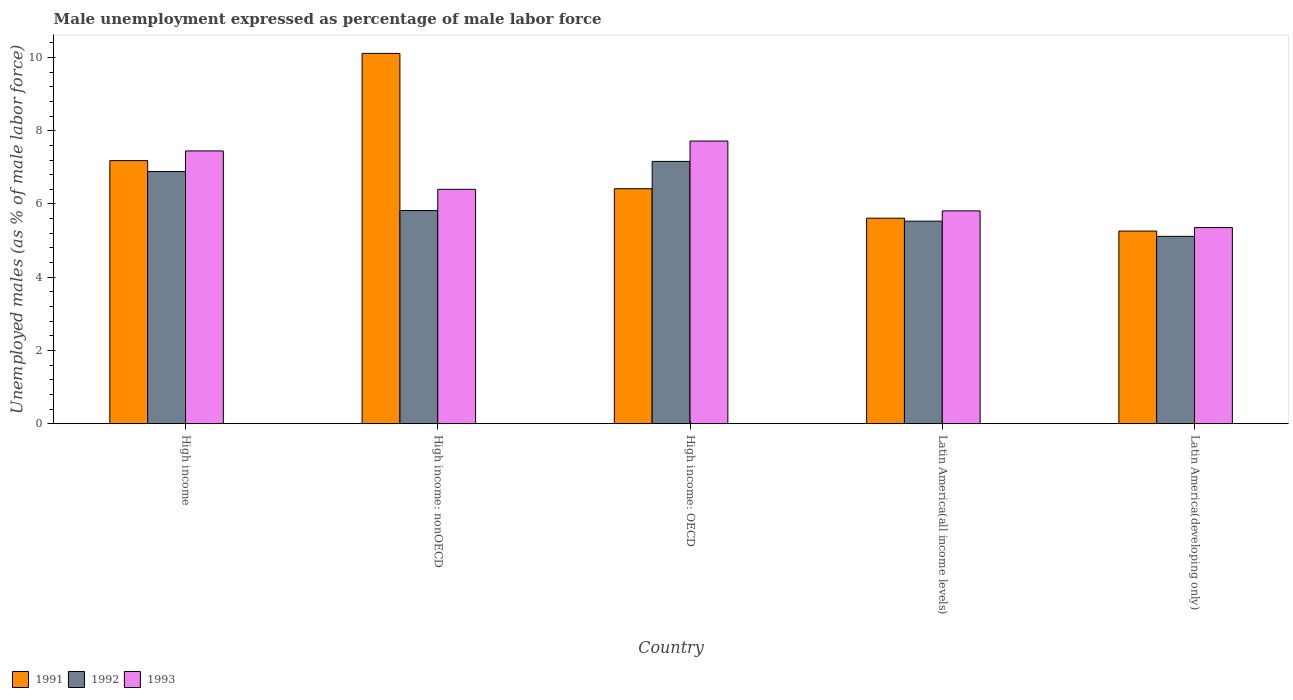How many groups of bars are there?
Make the answer very short. 5. Are the number of bars per tick equal to the number of legend labels?
Give a very brief answer. Yes. Are the number of bars on each tick of the X-axis equal?
Your answer should be compact. Yes. How many bars are there on the 3rd tick from the left?
Your answer should be compact. 3. What is the label of the 3rd group of bars from the left?
Ensure brevity in your answer.  High income: OECD. What is the unemployment in males in in 1992 in Latin America(developing only)?
Ensure brevity in your answer.  5.12. Across all countries, what is the maximum unemployment in males in in 1992?
Offer a terse response. 7.16. Across all countries, what is the minimum unemployment in males in in 1993?
Your response must be concise. 5.36. In which country was the unemployment in males in in 1993 maximum?
Offer a terse response. High income: OECD. In which country was the unemployment in males in in 1993 minimum?
Your response must be concise. Latin America(developing only). What is the total unemployment in males in in 1991 in the graph?
Offer a very short reply. 34.59. What is the difference between the unemployment in males in in 1993 in High income: nonOECD and that in Latin America(developing only)?
Your answer should be compact. 1.04. What is the difference between the unemployment in males in in 1993 in Latin America(all income levels) and the unemployment in males in in 1991 in High income: OECD?
Make the answer very short. -0.6. What is the average unemployment in males in in 1992 per country?
Offer a very short reply. 6.1. What is the difference between the unemployment in males in of/in 1991 and unemployment in males in of/in 1992 in High income: OECD?
Provide a short and direct response. -0.75. What is the ratio of the unemployment in males in in 1992 in High income: OECD to that in Latin America(developing only)?
Offer a terse response. 1.4. Is the unemployment in males in in 1993 in Latin America(all income levels) less than that in Latin America(developing only)?
Offer a very short reply. No. Is the difference between the unemployment in males in in 1991 in High income: OECD and High income: nonOECD greater than the difference between the unemployment in males in in 1992 in High income: OECD and High income: nonOECD?
Give a very brief answer. No. What is the difference between the highest and the second highest unemployment in males in in 1993?
Provide a succinct answer. 1.05. What is the difference between the highest and the lowest unemployment in males in in 1992?
Make the answer very short. 2.05. In how many countries, is the unemployment in males in in 1991 greater than the average unemployment in males in in 1991 taken over all countries?
Provide a succinct answer. 2. Is the sum of the unemployment in males in in 1992 in High income: OECD and High income: nonOECD greater than the maximum unemployment in males in in 1991 across all countries?
Your answer should be very brief. Yes. Are all the bars in the graph horizontal?
Ensure brevity in your answer.  No. What is the difference between two consecutive major ticks on the Y-axis?
Offer a terse response. 2. Does the graph contain any zero values?
Offer a very short reply. No. Where does the legend appear in the graph?
Provide a succinct answer. Bottom left. How are the legend labels stacked?
Offer a very short reply. Horizontal. What is the title of the graph?
Your response must be concise. Male unemployment expressed as percentage of male labor force. What is the label or title of the X-axis?
Give a very brief answer. Country. What is the label or title of the Y-axis?
Offer a very short reply. Unemployed males (as % of male labor force). What is the Unemployed males (as % of male labor force) of 1991 in High income?
Make the answer very short. 7.18. What is the Unemployed males (as % of male labor force) in 1992 in High income?
Provide a short and direct response. 6.89. What is the Unemployed males (as % of male labor force) of 1993 in High income?
Offer a very short reply. 7.45. What is the Unemployed males (as % of male labor force) of 1991 in High income: nonOECD?
Ensure brevity in your answer.  10.11. What is the Unemployed males (as % of male labor force) of 1992 in High income: nonOECD?
Your answer should be very brief. 5.82. What is the Unemployed males (as % of male labor force) in 1993 in High income: nonOECD?
Your response must be concise. 6.4. What is the Unemployed males (as % of male labor force) of 1991 in High income: OECD?
Offer a very short reply. 6.42. What is the Unemployed males (as % of male labor force) in 1992 in High income: OECD?
Your answer should be compact. 7.16. What is the Unemployed males (as % of male labor force) in 1993 in High income: OECD?
Offer a terse response. 7.72. What is the Unemployed males (as % of male labor force) in 1991 in Latin America(all income levels)?
Provide a short and direct response. 5.61. What is the Unemployed males (as % of male labor force) of 1992 in Latin America(all income levels)?
Make the answer very short. 5.53. What is the Unemployed males (as % of male labor force) of 1993 in Latin America(all income levels)?
Your answer should be very brief. 5.81. What is the Unemployed males (as % of male labor force) in 1991 in Latin America(developing only)?
Ensure brevity in your answer.  5.26. What is the Unemployed males (as % of male labor force) of 1992 in Latin America(developing only)?
Your answer should be very brief. 5.12. What is the Unemployed males (as % of male labor force) of 1993 in Latin America(developing only)?
Ensure brevity in your answer.  5.36. Across all countries, what is the maximum Unemployed males (as % of male labor force) in 1991?
Your response must be concise. 10.11. Across all countries, what is the maximum Unemployed males (as % of male labor force) in 1992?
Your answer should be compact. 7.16. Across all countries, what is the maximum Unemployed males (as % of male labor force) in 1993?
Your response must be concise. 7.72. Across all countries, what is the minimum Unemployed males (as % of male labor force) in 1991?
Provide a short and direct response. 5.26. Across all countries, what is the minimum Unemployed males (as % of male labor force) of 1992?
Provide a succinct answer. 5.12. Across all countries, what is the minimum Unemployed males (as % of male labor force) of 1993?
Make the answer very short. 5.36. What is the total Unemployed males (as % of male labor force) in 1991 in the graph?
Provide a short and direct response. 34.59. What is the total Unemployed males (as % of male labor force) in 1992 in the graph?
Your response must be concise. 30.52. What is the total Unemployed males (as % of male labor force) in 1993 in the graph?
Provide a succinct answer. 32.74. What is the difference between the Unemployed males (as % of male labor force) of 1991 in High income and that in High income: nonOECD?
Offer a terse response. -2.93. What is the difference between the Unemployed males (as % of male labor force) in 1992 in High income and that in High income: nonOECD?
Provide a succinct answer. 1.06. What is the difference between the Unemployed males (as % of male labor force) of 1993 in High income and that in High income: nonOECD?
Ensure brevity in your answer.  1.05. What is the difference between the Unemployed males (as % of male labor force) of 1991 in High income and that in High income: OECD?
Give a very brief answer. 0.77. What is the difference between the Unemployed males (as % of male labor force) of 1992 in High income and that in High income: OECD?
Provide a succinct answer. -0.28. What is the difference between the Unemployed males (as % of male labor force) of 1993 in High income and that in High income: OECD?
Ensure brevity in your answer.  -0.27. What is the difference between the Unemployed males (as % of male labor force) in 1991 in High income and that in Latin America(all income levels)?
Your answer should be very brief. 1.57. What is the difference between the Unemployed males (as % of male labor force) in 1992 in High income and that in Latin America(all income levels)?
Your answer should be compact. 1.36. What is the difference between the Unemployed males (as % of male labor force) of 1993 in High income and that in Latin America(all income levels)?
Make the answer very short. 1.64. What is the difference between the Unemployed males (as % of male labor force) in 1991 in High income and that in Latin America(developing only)?
Offer a very short reply. 1.92. What is the difference between the Unemployed males (as % of male labor force) in 1992 in High income and that in Latin America(developing only)?
Provide a succinct answer. 1.77. What is the difference between the Unemployed males (as % of male labor force) in 1993 in High income and that in Latin America(developing only)?
Give a very brief answer. 2.09. What is the difference between the Unemployed males (as % of male labor force) of 1991 in High income: nonOECD and that in High income: OECD?
Provide a succinct answer. 3.7. What is the difference between the Unemployed males (as % of male labor force) in 1992 in High income: nonOECD and that in High income: OECD?
Your response must be concise. -1.34. What is the difference between the Unemployed males (as % of male labor force) of 1993 in High income: nonOECD and that in High income: OECD?
Make the answer very short. -1.32. What is the difference between the Unemployed males (as % of male labor force) in 1991 in High income: nonOECD and that in Latin America(all income levels)?
Make the answer very short. 4.5. What is the difference between the Unemployed males (as % of male labor force) in 1992 in High income: nonOECD and that in Latin America(all income levels)?
Your response must be concise. 0.29. What is the difference between the Unemployed males (as % of male labor force) in 1993 in High income: nonOECD and that in Latin America(all income levels)?
Keep it short and to the point. 0.59. What is the difference between the Unemployed males (as % of male labor force) in 1991 in High income: nonOECD and that in Latin America(developing only)?
Offer a very short reply. 4.85. What is the difference between the Unemployed males (as % of male labor force) in 1992 in High income: nonOECD and that in Latin America(developing only)?
Provide a short and direct response. 0.7. What is the difference between the Unemployed males (as % of male labor force) of 1993 in High income: nonOECD and that in Latin America(developing only)?
Your answer should be very brief. 1.04. What is the difference between the Unemployed males (as % of male labor force) of 1991 in High income: OECD and that in Latin America(all income levels)?
Your answer should be very brief. 0.8. What is the difference between the Unemployed males (as % of male labor force) of 1992 in High income: OECD and that in Latin America(all income levels)?
Provide a short and direct response. 1.63. What is the difference between the Unemployed males (as % of male labor force) of 1993 in High income: OECD and that in Latin America(all income levels)?
Ensure brevity in your answer.  1.91. What is the difference between the Unemployed males (as % of male labor force) in 1991 in High income: OECD and that in Latin America(developing only)?
Provide a succinct answer. 1.16. What is the difference between the Unemployed males (as % of male labor force) of 1992 in High income: OECD and that in Latin America(developing only)?
Provide a short and direct response. 2.05. What is the difference between the Unemployed males (as % of male labor force) in 1993 in High income: OECD and that in Latin America(developing only)?
Provide a succinct answer. 2.36. What is the difference between the Unemployed males (as % of male labor force) of 1991 in Latin America(all income levels) and that in Latin America(developing only)?
Make the answer very short. 0.35. What is the difference between the Unemployed males (as % of male labor force) of 1992 in Latin America(all income levels) and that in Latin America(developing only)?
Offer a terse response. 0.41. What is the difference between the Unemployed males (as % of male labor force) of 1993 in Latin America(all income levels) and that in Latin America(developing only)?
Provide a short and direct response. 0.46. What is the difference between the Unemployed males (as % of male labor force) in 1991 in High income and the Unemployed males (as % of male labor force) in 1992 in High income: nonOECD?
Your answer should be very brief. 1.36. What is the difference between the Unemployed males (as % of male labor force) in 1991 in High income and the Unemployed males (as % of male labor force) in 1993 in High income: nonOECD?
Your response must be concise. 0.78. What is the difference between the Unemployed males (as % of male labor force) of 1992 in High income and the Unemployed males (as % of male labor force) of 1993 in High income: nonOECD?
Your answer should be compact. 0.49. What is the difference between the Unemployed males (as % of male labor force) in 1991 in High income and the Unemployed males (as % of male labor force) in 1992 in High income: OECD?
Provide a short and direct response. 0.02. What is the difference between the Unemployed males (as % of male labor force) of 1991 in High income and the Unemployed males (as % of male labor force) of 1993 in High income: OECD?
Give a very brief answer. -0.53. What is the difference between the Unemployed males (as % of male labor force) of 1992 in High income and the Unemployed males (as % of male labor force) of 1993 in High income: OECD?
Offer a terse response. -0.83. What is the difference between the Unemployed males (as % of male labor force) in 1991 in High income and the Unemployed males (as % of male labor force) in 1992 in Latin America(all income levels)?
Your answer should be compact. 1.65. What is the difference between the Unemployed males (as % of male labor force) of 1991 in High income and the Unemployed males (as % of male labor force) of 1993 in Latin America(all income levels)?
Your response must be concise. 1.37. What is the difference between the Unemployed males (as % of male labor force) of 1992 in High income and the Unemployed males (as % of male labor force) of 1993 in Latin America(all income levels)?
Your answer should be very brief. 1.07. What is the difference between the Unemployed males (as % of male labor force) of 1991 in High income and the Unemployed males (as % of male labor force) of 1992 in Latin America(developing only)?
Your response must be concise. 2.07. What is the difference between the Unemployed males (as % of male labor force) in 1991 in High income and the Unemployed males (as % of male labor force) in 1993 in Latin America(developing only)?
Your response must be concise. 1.83. What is the difference between the Unemployed males (as % of male labor force) of 1992 in High income and the Unemployed males (as % of male labor force) of 1993 in Latin America(developing only)?
Keep it short and to the point. 1.53. What is the difference between the Unemployed males (as % of male labor force) of 1991 in High income: nonOECD and the Unemployed males (as % of male labor force) of 1992 in High income: OECD?
Make the answer very short. 2.95. What is the difference between the Unemployed males (as % of male labor force) in 1991 in High income: nonOECD and the Unemployed males (as % of male labor force) in 1993 in High income: OECD?
Keep it short and to the point. 2.39. What is the difference between the Unemployed males (as % of male labor force) of 1992 in High income: nonOECD and the Unemployed males (as % of male labor force) of 1993 in High income: OECD?
Make the answer very short. -1.9. What is the difference between the Unemployed males (as % of male labor force) in 1991 in High income: nonOECD and the Unemployed males (as % of male labor force) in 1992 in Latin America(all income levels)?
Make the answer very short. 4.58. What is the difference between the Unemployed males (as % of male labor force) of 1991 in High income: nonOECD and the Unemployed males (as % of male labor force) of 1993 in Latin America(all income levels)?
Give a very brief answer. 4.3. What is the difference between the Unemployed males (as % of male labor force) of 1992 in High income: nonOECD and the Unemployed males (as % of male labor force) of 1993 in Latin America(all income levels)?
Provide a succinct answer. 0.01. What is the difference between the Unemployed males (as % of male labor force) in 1991 in High income: nonOECD and the Unemployed males (as % of male labor force) in 1992 in Latin America(developing only)?
Provide a succinct answer. 5. What is the difference between the Unemployed males (as % of male labor force) in 1991 in High income: nonOECD and the Unemployed males (as % of male labor force) in 1993 in Latin America(developing only)?
Your answer should be very brief. 4.76. What is the difference between the Unemployed males (as % of male labor force) in 1992 in High income: nonOECD and the Unemployed males (as % of male labor force) in 1993 in Latin America(developing only)?
Give a very brief answer. 0.47. What is the difference between the Unemployed males (as % of male labor force) of 1991 in High income: OECD and the Unemployed males (as % of male labor force) of 1992 in Latin America(all income levels)?
Your answer should be very brief. 0.89. What is the difference between the Unemployed males (as % of male labor force) in 1991 in High income: OECD and the Unemployed males (as % of male labor force) in 1993 in Latin America(all income levels)?
Keep it short and to the point. 0.6. What is the difference between the Unemployed males (as % of male labor force) in 1992 in High income: OECD and the Unemployed males (as % of male labor force) in 1993 in Latin America(all income levels)?
Give a very brief answer. 1.35. What is the difference between the Unemployed males (as % of male labor force) of 1991 in High income: OECD and the Unemployed males (as % of male labor force) of 1992 in Latin America(developing only)?
Provide a short and direct response. 1.3. What is the difference between the Unemployed males (as % of male labor force) in 1991 in High income: OECD and the Unemployed males (as % of male labor force) in 1993 in Latin America(developing only)?
Offer a terse response. 1.06. What is the difference between the Unemployed males (as % of male labor force) of 1992 in High income: OECD and the Unemployed males (as % of male labor force) of 1993 in Latin America(developing only)?
Keep it short and to the point. 1.81. What is the difference between the Unemployed males (as % of male labor force) in 1991 in Latin America(all income levels) and the Unemployed males (as % of male labor force) in 1992 in Latin America(developing only)?
Offer a very short reply. 0.5. What is the difference between the Unemployed males (as % of male labor force) of 1991 in Latin America(all income levels) and the Unemployed males (as % of male labor force) of 1993 in Latin America(developing only)?
Your response must be concise. 0.26. What is the difference between the Unemployed males (as % of male labor force) in 1992 in Latin America(all income levels) and the Unemployed males (as % of male labor force) in 1993 in Latin America(developing only)?
Your answer should be very brief. 0.18. What is the average Unemployed males (as % of male labor force) in 1991 per country?
Keep it short and to the point. 6.92. What is the average Unemployed males (as % of male labor force) in 1992 per country?
Make the answer very short. 6.1. What is the average Unemployed males (as % of male labor force) in 1993 per country?
Your answer should be compact. 6.55. What is the difference between the Unemployed males (as % of male labor force) in 1991 and Unemployed males (as % of male labor force) in 1992 in High income?
Provide a short and direct response. 0.3. What is the difference between the Unemployed males (as % of male labor force) in 1991 and Unemployed males (as % of male labor force) in 1993 in High income?
Give a very brief answer. -0.26. What is the difference between the Unemployed males (as % of male labor force) in 1992 and Unemployed males (as % of male labor force) in 1993 in High income?
Provide a short and direct response. -0.56. What is the difference between the Unemployed males (as % of male labor force) in 1991 and Unemployed males (as % of male labor force) in 1992 in High income: nonOECD?
Provide a succinct answer. 4.29. What is the difference between the Unemployed males (as % of male labor force) in 1991 and Unemployed males (as % of male labor force) in 1993 in High income: nonOECD?
Your answer should be very brief. 3.71. What is the difference between the Unemployed males (as % of male labor force) in 1992 and Unemployed males (as % of male labor force) in 1993 in High income: nonOECD?
Your response must be concise. -0.58. What is the difference between the Unemployed males (as % of male labor force) of 1991 and Unemployed males (as % of male labor force) of 1992 in High income: OECD?
Your answer should be compact. -0.75. What is the difference between the Unemployed males (as % of male labor force) of 1991 and Unemployed males (as % of male labor force) of 1993 in High income: OECD?
Offer a very short reply. -1.3. What is the difference between the Unemployed males (as % of male labor force) in 1992 and Unemployed males (as % of male labor force) in 1993 in High income: OECD?
Offer a very short reply. -0.56. What is the difference between the Unemployed males (as % of male labor force) of 1991 and Unemployed males (as % of male labor force) of 1992 in Latin America(all income levels)?
Offer a terse response. 0.08. What is the difference between the Unemployed males (as % of male labor force) of 1991 and Unemployed males (as % of male labor force) of 1993 in Latin America(all income levels)?
Your answer should be very brief. -0.2. What is the difference between the Unemployed males (as % of male labor force) of 1992 and Unemployed males (as % of male labor force) of 1993 in Latin America(all income levels)?
Provide a succinct answer. -0.28. What is the difference between the Unemployed males (as % of male labor force) of 1991 and Unemployed males (as % of male labor force) of 1992 in Latin America(developing only)?
Offer a very short reply. 0.14. What is the difference between the Unemployed males (as % of male labor force) of 1991 and Unemployed males (as % of male labor force) of 1993 in Latin America(developing only)?
Keep it short and to the point. -0.1. What is the difference between the Unemployed males (as % of male labor force) of 1992 and Unemployed males (as % of male labor force) of 1993 in Latin America(developing only)?
Give a very brief answer. -0.24. What is the ratio of the Unemployed males (as % of male labor force) in 1991 in High income to that in High income: nonOECD?
Ensure brevity in your answer.  0.71. What is the ratio of the Unemployed males (as % of male labor force) of 1992 in High income to that in High income: nonOECD?
Provide a short and direct response. 1.18. What is the ratio of the Unemployed males (as % of male labor force) of 1993 in High income to that in High income: nonOECD?
Offer a very short reply. 1.16. What is the ratio of the Unemployed males (as % of male labor force) in 1991 in High income to that in High income: OECD?
Ensure brevity in your answer.  1.12. What is the ratio of the Unemployed males (as % of male labor force) in 1992 in High income to that in High income: OECD?
Provide a short and direct response. 0.96. What is the ratio of the Unemployed males (as % of male labor force) in 1993 in High income to that in High income: OECD?
Offer a terse response. 0.97. What is the ratio of the Unemployed males (as % of male labor force) in 1991 in High income to that in Latin America(all income levels)?
Keep it short and to the point. 1.28. What is the ratio of the Unemployed males (as % of male labor force) in 1992 in High income to that in Latin America(all income levels)?
Provide a short and direct response. 1.25. What is the ratio of the Unemployed males (as % of male labor force) in 1993 in High income to that in Latin America(all income levels)?
Offer a terse response. 1.28. What is the ratio of the Unemployed males (as % of male labor force) of 1991 in High income to that in Latin America(developing only)?
Provide a short and direct response. 1.37. What is the ratio of the Unemployed males (as % of male labor force) of 1992 in High income to that in Latin America(developing only)?
Make the answer very short. 1.35. What is the ratio of the Unemployed males (as % of male labor force) in 1993 in High income to that in Latin America(developing only)?
Make the answer very short. 1.39. What is the ratio of the Unemployed males (as % of male labor force) of 1991 in High income: nonOECD to that in High income: OECD?
Provide a short and direct response. 1.58. What is the ratio of the Unemployed males (as % of male labor force) in 1992 in High income: nonOECD to that in High income: OECD?
Ensure brevity in your answer.  0.81. What is the ratio of the Unemployed males (as % of male labor force) of 1993 in High income: nonOECD to that in High income: OECD?
Keep it short and to the point. 0.83. What is the ratio of the Unemployed males (as % of male labor force) in 1991 in High income: nonOECD to that in Latin America(all income levels)?
Give a very brief answer. 1.8. What is the ratio of the Unemployed males (as % of male labor force) in 1992 in High income: nonOECD to that in Latin America(all income levels)?
Ensure brevity in your answer.  1.05. What is the ratio of the Unemployed males (as % of male labor force) of 1993 in High income: nonOECD to that in Latin America(all income levels)?
Offer a terse response. 1.1. What is the ratio of the Unemployed males (as % of male labor force) of 1991 in High income: nonOECD to that in Latin America(developing only)?
Ensure brevity in your answer.  1.92. What is the ratio of the Unemployed males (as % of male labor force) of 1992 in High income: nonOECD to that in Latin America(developing only)?
Provide a short and direct response. 1.14. What is the ratio of the Unemployed males (as % of male labor force) in 1993 in High income: nonOECD to that in Latin America(developing only)?
Give a very brief answer. 1.2. What is the ratio of the Unemployed males (as % of male labor force) of 1991 in High income: OECD to that in Latin America(all income levels)?
Make the answer very short. 1.14. What is the ratio of the Unemployed males (as % of male labor force) of 1992 in High income: OECD to that in Latin America(all income levels)?
Provide a short and direct response. 1.29. What is the ratio of the Unemployed males (as % of male labor force) of 1993 in High income: OECD to that in Latin America(all income levels)?
Your response must be concise. 1.33. What is the ratio of the Unemployed males (as % of male labor force) of 1991 in High income: OECD to that in Latin America(developing only)?
Ensure brevity in your answer.  1.22. What is the ratio of the Unemployed males (as % of male labor force) of 1992 in High income: OECD to that in Latin America(developing only)?
Provide a succinct answer. 1.4. What is the ratio of the Unemployed males (as % of male labor force) of 1993 in High income: OECD to that in Latin America(developing only)?
Make the answer very short. 1.44. What is the ratio of the Unemployed males (as % of male labor force) in 1991 in Latin America(all income levels) to that in Latin America(developing only)?
Offer a terse response. 1.07. What is the ratio of the Unemployed males (as % of male labor force) in 1992 in Latin America(all income levels) to that in Latin America(developing only)?
Ensure brevity in your answer.  1.08. What is the ratio of the Unemployed males (as % of male labor force) of 1993 in Latin America(all income levels) to that in Latin America(developing only)?
Keep it short and to the point. 1.09. What is the difference between the highest and the second highest Unemployed males (as % of male labor force) of 1991?
Keep it short and to the point. 2.93. What is the difference between the highest and the second highest Unemployed males (as % of male labor force) in 1992?
Offer a very short reply. 0.28. What is the difference between the highest and the second highest Unemployed males (as % of male labor force) of 1993?
Offer a very short reply. 0.27. What is the difference between the highest and the lowest Unemployed males (as % of male labor force) in 1991?
Keep it short and to the point. 4.85. What is the difference between the highest and the lowest Unemployed males (as % of male labor force) of 1992?
Your answer should be compact. 2.05. What is the difference between the highest and the lowest Unemployed males (as % of male labor force) in 1993?
Offer a very short reply. 2.36. 